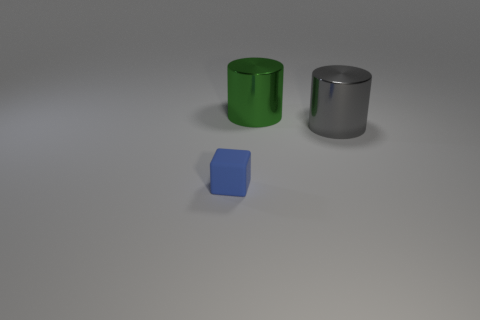Add 3 small blue rubber objects. How many objects exist? 6 Subtract all cylinders. How many objects are left? 1 Subtract all big gray metallic things. Subtract all large gray things. How many objects are left? 1 Add 1 rubber cubes. How many rubber cubes are left? 2 Add 2 green objects. How many green objects exist? 3 Subtract 0 blue cylinders. How many objects are left? 3 